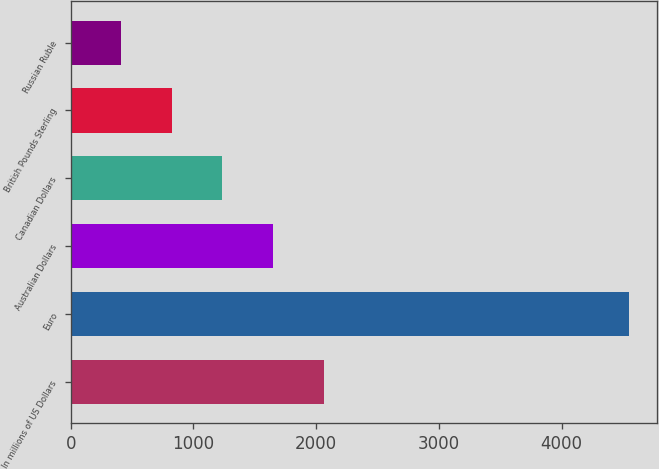Convert chart. <chart><loc_0><loc_0><loc_500><loc_500><bar_chart><fcel>In millions of US Dollars<fcel>Euro<fcel>Australian Dollars<fcel>Canadian Dollars<fcel>British Pounds Sterling<fcel>Russian Ruble<nl><fcel>2064.6<fcel>4551<fcel>1650.2<fcel>1235.8<fcel>821.4<fcel>407<nl></chart> 